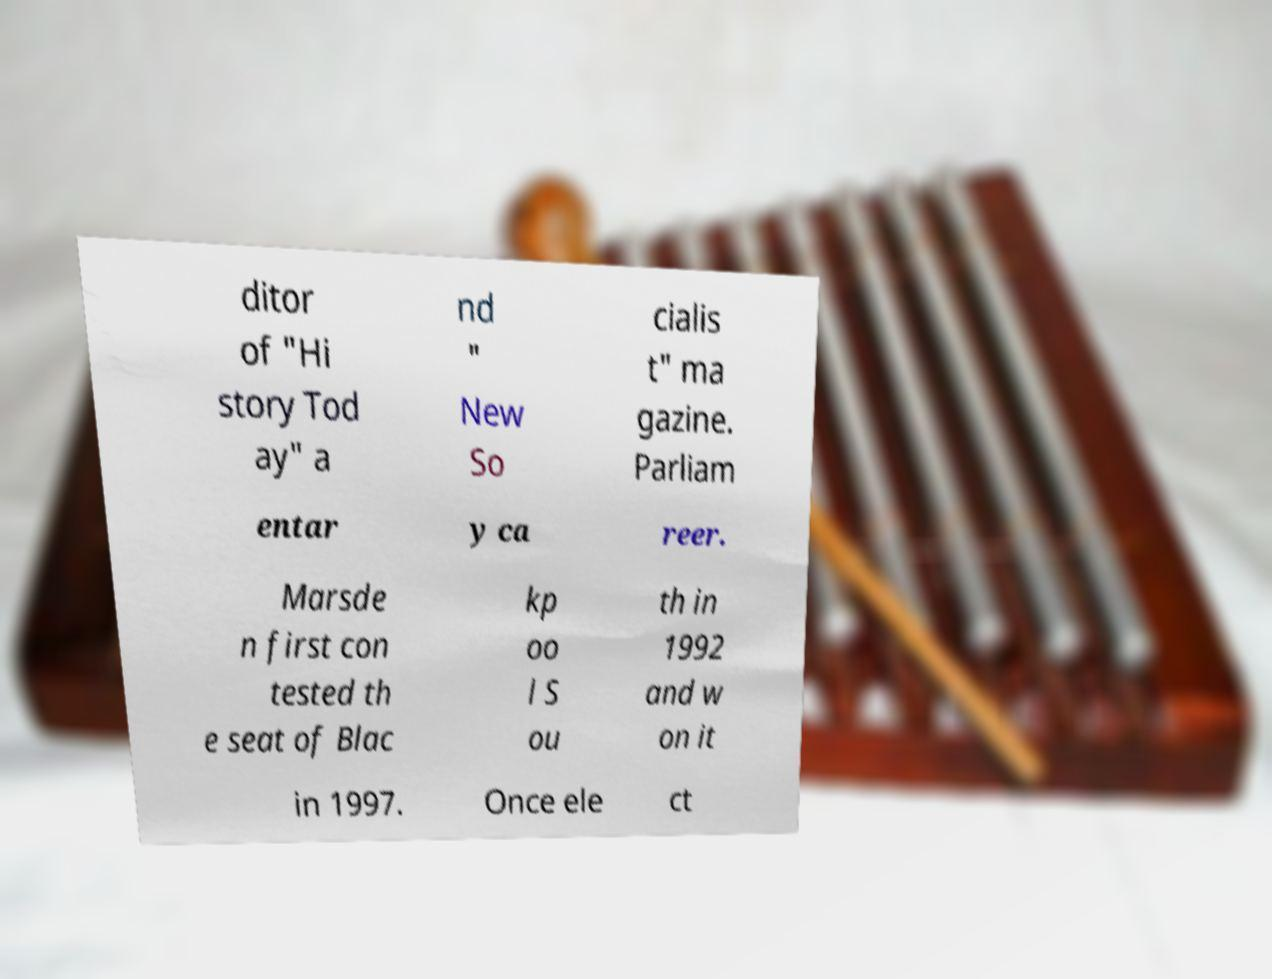I need the written content from this picture converted into text. Can you do that? ditor of "Hi story Tod ay" a nd " New So cialis t" ma gazine. Parliam entar y ca reer. Marsde n first con tested th e seat of Blac kp oo l S ou th in 1992 and w on it in 1997. Once ele ct 